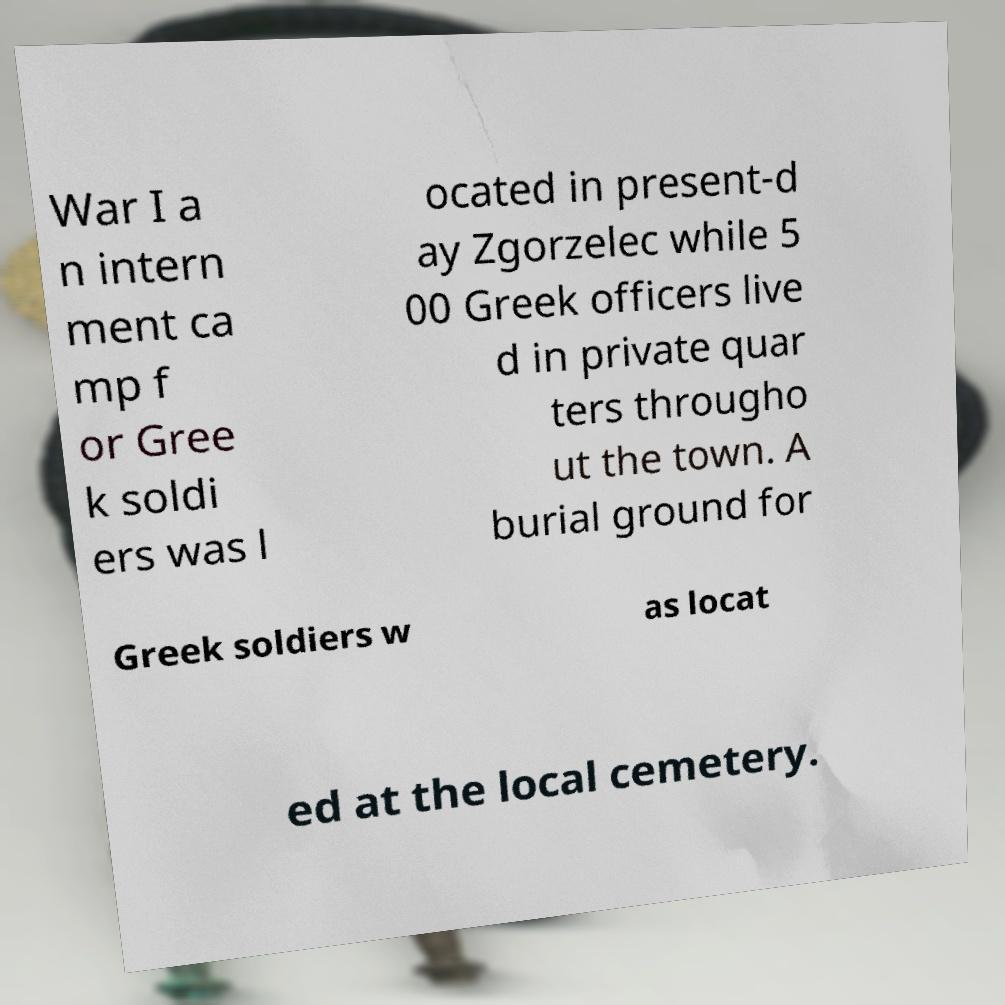For documentation purposes, I need the text within this image transcribed. Could you provide that? War I a n intern ment ca mp f or Gree k soldi ers was l ocated in present-d ay Zgorzelec while 5 00 Greek officers live d in private quar ters througho ut the town. A burial ground for Greek soldiers w as locat ed at the local cemetery. 